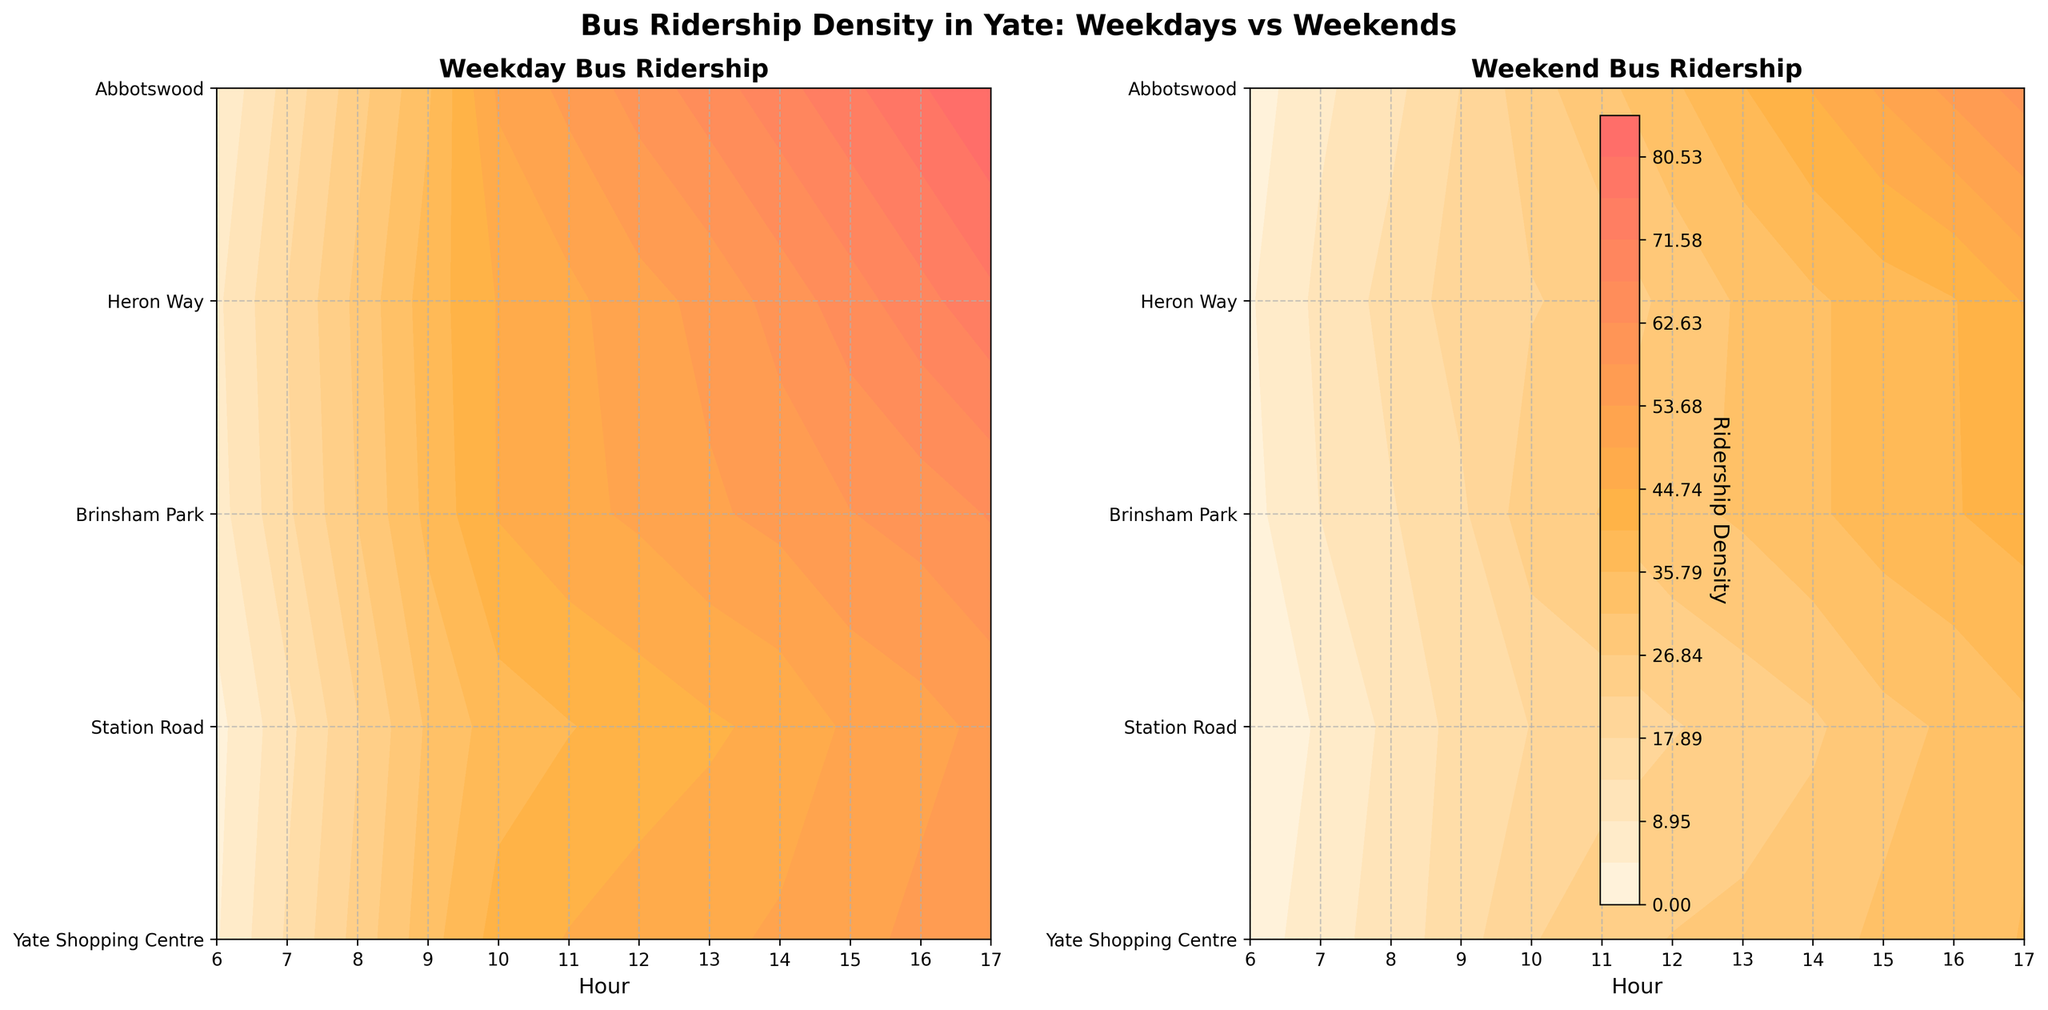What's the title of the figure? The title is located at the top center of the figure in bold font. It reads "Bus Ridership Density in Yate: Weekdays vs Weekends".
Answer: Bus Ridership Density in Yate: Weekdays vs Weekends What are the x-axis labels? The x-axis labels represent the hours of the day and are displaying the range from 6 to 17.
Answer: Hours Which location has the highest weekday ridership between 12 PM and 1 PM? By looking at the left plot, "Weekday Bus Ridership", and locating the row for each location, Yate Shopping Centre has the highest contour density at that time interval.
Answer: Yate Shopping Centre How does the ridership at Heron Way change between weekdays and weekends at 10 AM? By comparing the contour levels at 10 AM for Heron Way between the two plots, the weekday ridership is notably higher than the weekend ridership.
Answer: Weekday ridership is higher Which hour shows the largest increase in ridership from weekends to weekdays at Station Road? By comparing both plots for Station Road, the largest increase in contour levels is observed at 8 AM.
Answer: 8 AM What is the ridership density color gradient used in the figure? The gradient goes from light yellow to orange to red, indicating an increase in ridership density from low to high.
Answer: Light yellow to red Do any locations have more weekend ridership than weekday ridership at any hour? By examining both plots, there is no contour area where the weekend plot has higher levels than the weekday plot for any hour at any location.
Answer: No Which location has the lowest weekend ridership at 7 AM? By referencing the right plot, "Weekend Bus Ridership", and locating the 7 AM column, Brinsham Park has the lowest ridership density.
Answer: Brinsham Park At which location does ridership peak the earliest on weekdays? By examining the left plot, "Weekday Bus Ridership", it is seen that ridership peaks earliest at Station Road around 7 AM.
Answer: Station Road 